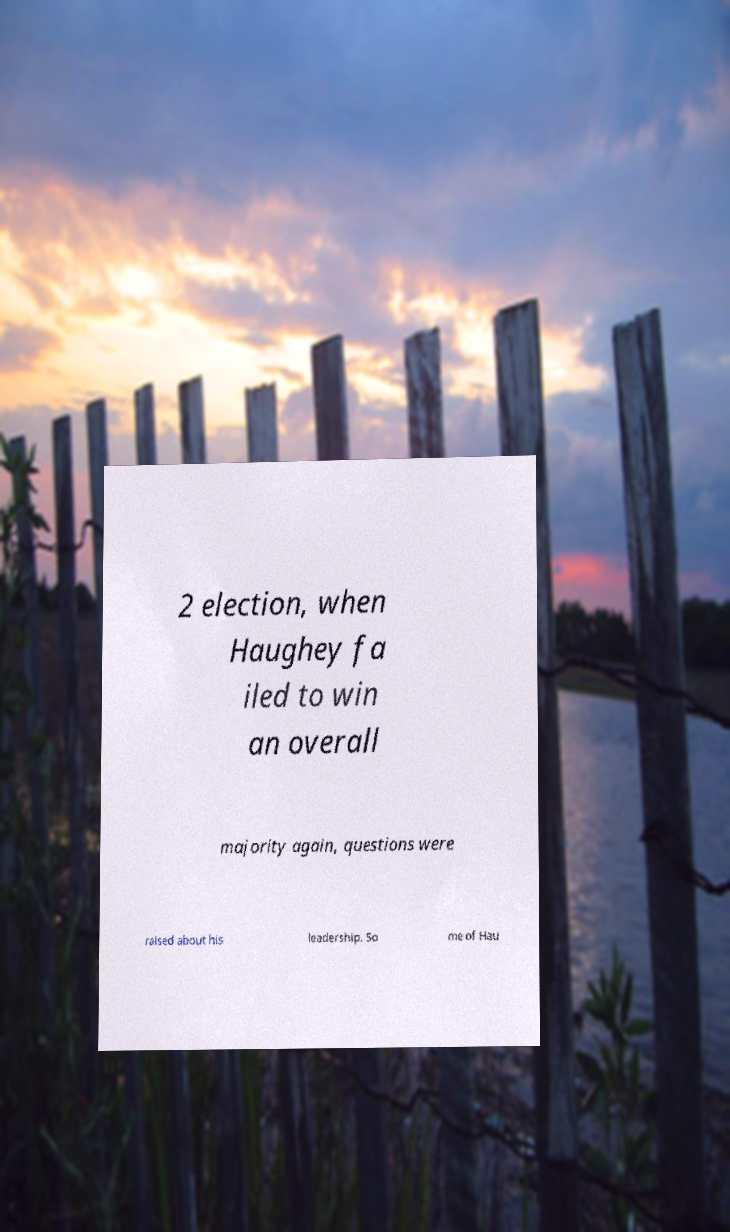What messages or text are displayed in this image? I need them in a readable, typed format. 2 election, when Haughey fa iled to win an overall majority again, questions were raised about his leadership. So me of Hau 